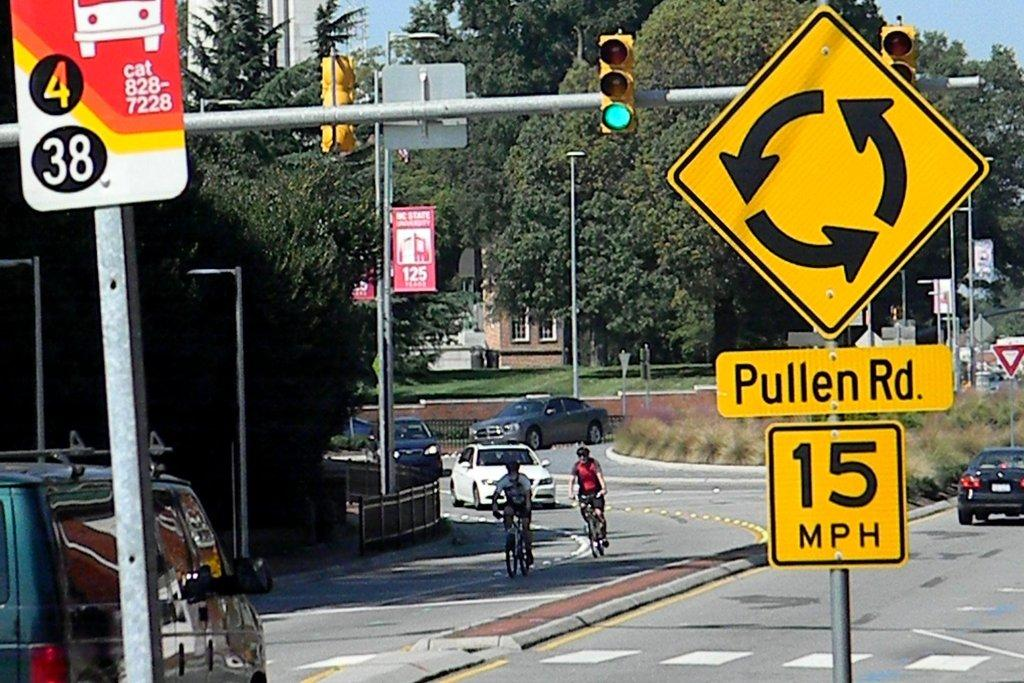<image>
Describe the image concisely. Pullen Road features a traffic circle, and the speed limit is 15 miles per hour. 